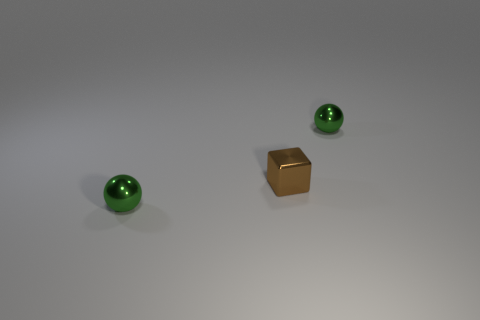What number of spheres are green objects or tiny brown things?
Provide a short and direct response. 2. Are any tiny blue objects visible?
Your response must be concise. No. There is a small green thing that is behind the small green shiny object that is in front of the brown thing; what shape is it?
Your answer should be very brief. Sphere. What number of brown objects are either tiny shiny balls or blocks?
Your answer should be very brief. 1. What is the color of the block?
Your response must be concise. Brown. Is there anything else that has the same shape as the brown thing?
Your answer should be very brief. No. There is a sphere that is on the left side of the green metal sphere behind the tiny green object in front of the brown shiny thing; how big is it?
Give a very brief answer. Small. How many other things are the same color as the tiny cube?
Ensure brevity in your answer.  0. There is a green sphere that is on the right side of the brown thing; how big is it?
Keep it short and to the point. Small. There is a tiny shiny object that is in front of the brown cube; is its color the same as the small metallic object that is behind the tiny brown metallic cube?
Your answer should be compact. Yes. 